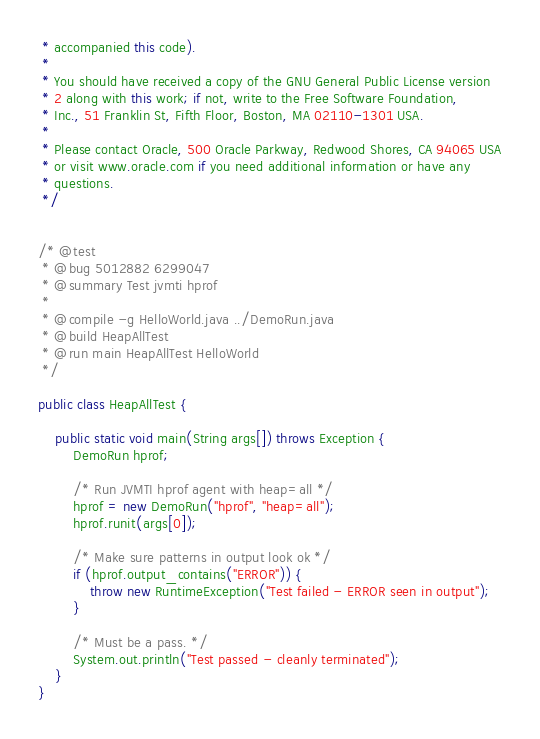Convert code to text. <code><loc_0><loc_0><loc_500><loc_500><_Java_> * accompanied this code).
 *
 * You should have received a copy of the GNU General Public License version
 * 2 along with this work; if not, write to the Free Software Foundation,
 * Inc., 51 Franklin St, Fifth Floor, Boston, MA 02110-1301 USA.
 *
 * Please contact Oracle, 500 Oracle Parkway, Redwood Shores, CA 94065 USA
 * or visit www.oracle.com if you need additional information or have any
 * questions.
 */


/* @test
 * @bug 5012882 6299047
 * @summary Test jvmti hprof
 *
 * @compile -g HelloWorld.java ../DemoRun.java
 * @build HeapAllTest
 * @run main HeapAllTest HelloWorld
 */

public class HeapAllTest {

    public static void main(String args[]) throws Exception {
        DemoRun hprof;

        /* Run JVMTI hprof agent with heap=all */
        hprof = new DemoRun("hprof", "heap=all");
        hprof.runit(args[0]);

        /* Make sure patterns in output look ok */
        if (hprof.output_contains("ERROR")) {
            throw new RuntimeException("Test failed - ERROR seen in output");
        }

        /* Must be a pass. */
        System.out.println("Test passed - cleanly terminated");
    }
}
</code> 